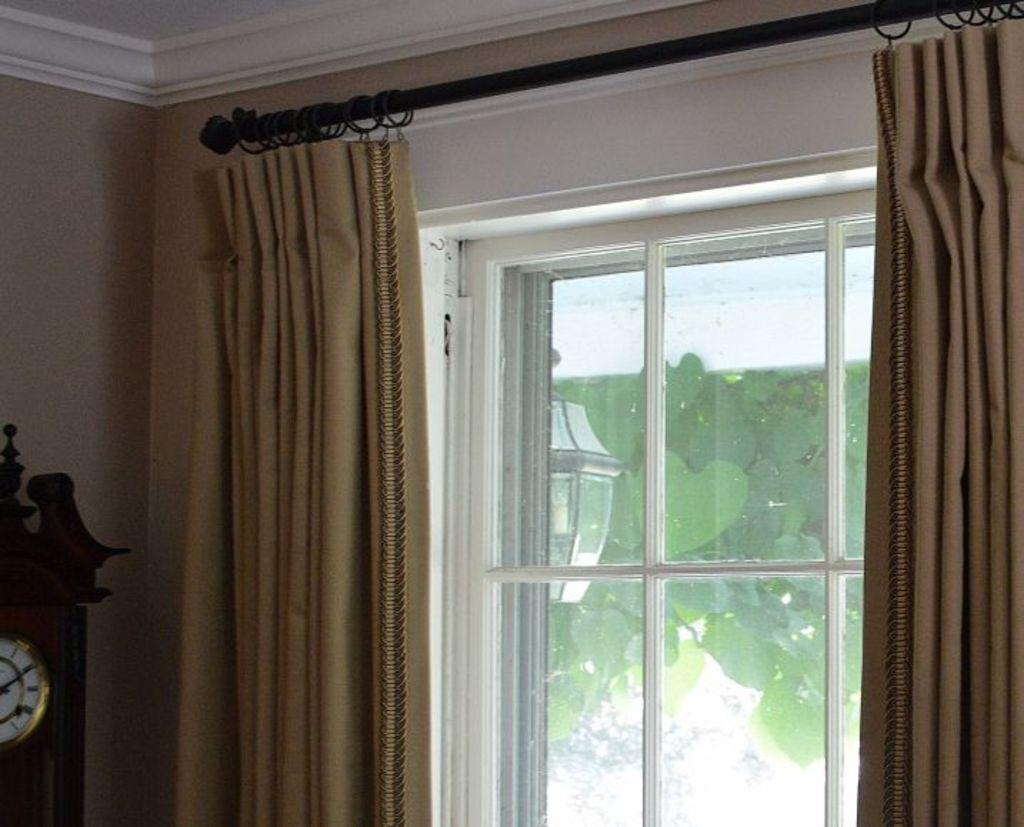What type of window treatment is present in the image? There are curtains in the image. What can be seen through the window in the image? Green leaves and a light are visible through the window. What time-telling device is present in the image? There is a clock in the image. What type of surface is the clock mounted on? The clock is mounted on a wall in the image. How many worms can be seen crawling on the clock in the image? There are no worms present in the image, and the clock is not crawling with any creatures. What is the amount of light visible through the window in the image? The question about the amount of light is not definitively answerable from the provided facts, as the intensity or brightness of the light is not mentioned. 